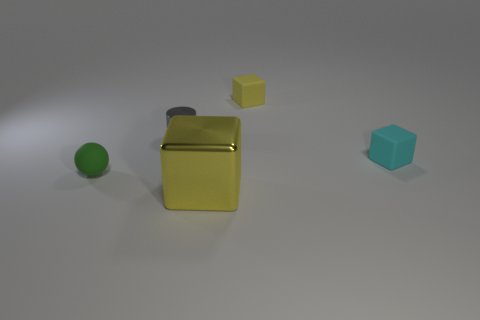Subtract all gray cubes. Subtract all yellow cylinders. How many cubes are left? 3 Add 5 blue cylinders. How many objects exist? 10 Subtract all cylinders. How many objects are left? 4 Subtract 0 yellow cylinders. How many objects are left? 5 Subtract all tiny green matte things. Subtract all small gray cylinders. How many objects are left? 3 Add 3 tiny green things. How many tiny green things are left? 4 Add 2 matte things. How many matte things exist? 5 